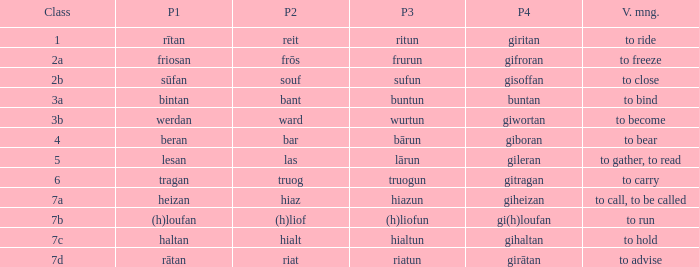What class in the word with part 4 "giheizan"? 7a. Parse the table in full. {'header': ['Class', 'P1', 'P2', 'P3', 'P4', 'V. mng.'], 'rows': [['1', 'rītan', 'reit', 'ritun', 'giritan', 'to ride'], ['2a', 'friosan', 'frōs', 'frurun', 'gifroran', 'to freeze'], ['2b', 'sūfan', 'souf', 'sufun', 'gisoffan', 'to close'], ['3a', 'bintan', 'bant', 'buntun', 'buntan', 'to bind'], ['3b', 'werdan', 'ward', 'wurtun', 'giwortan', 'to become'], ['4', 'beran', 'bar', 'bārun', 'giboran', 'to bear'], ['5', 'lesan', 'las', 'lārun', 'gileran', 'to gather, to read'], ['6', 'tragan', 'truog', 'truogun', 'gitragan', 'to carry'], ['7a', 'heizan', 'hiaz', 'hiazun', 'giheizan', 'to call, to be called'], ['7b', '(h)loufan', '(h)liof', '(h)liofun', 'gi(h)loufan', 'to run'], ['7c', 'haltan', 'hialt', 'hialtun', 'gihaltan', 'to hold'], ['7d', 'rātan', 'riat', 'riatun', 'girātan', 'to advise']]} 